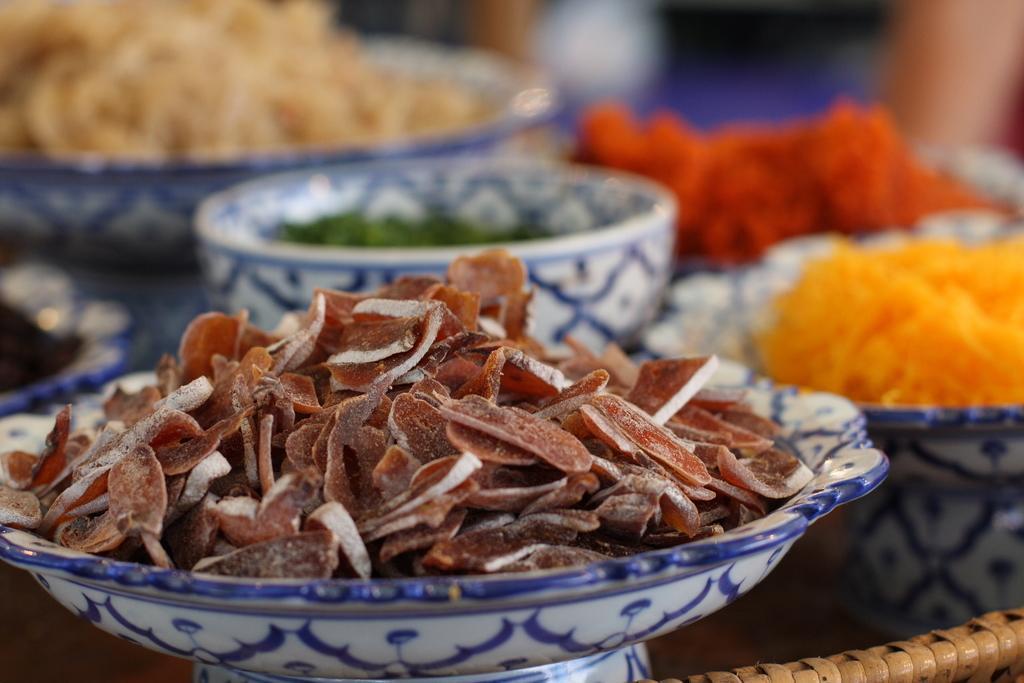How would you summarize this image in a sentence or two? In this image we can see food in the bowls placed on the table. 